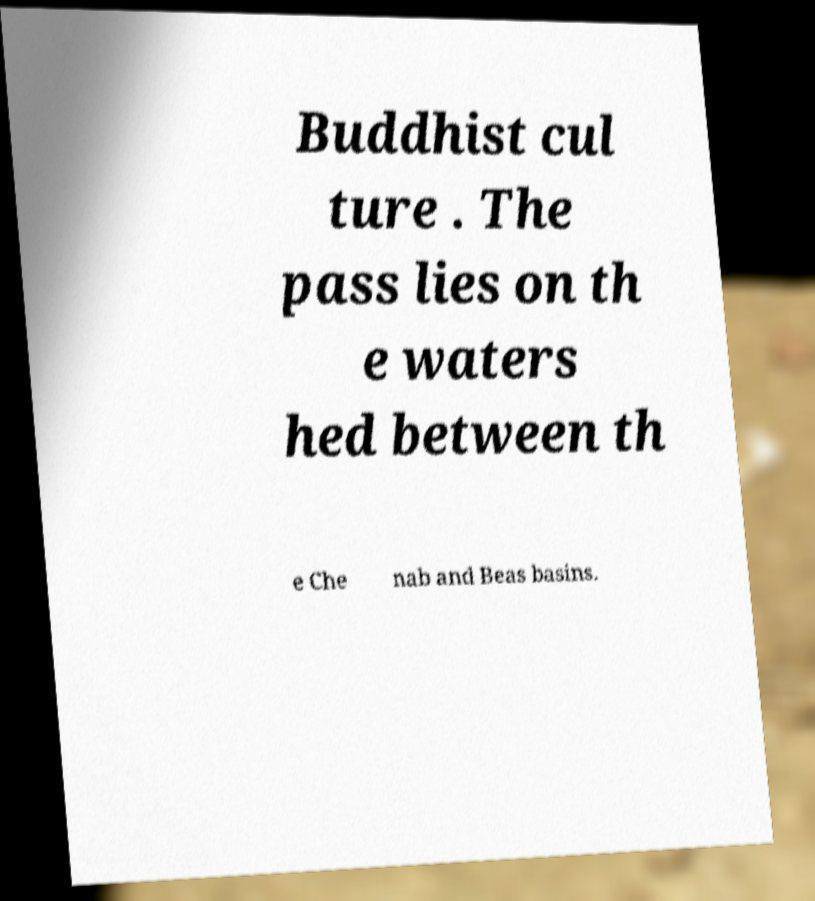Could you assist in decoding the text presented in this image and type it out clearly? Buddhist cul ture . The pass lies on th e waters hed between th e Che nab and Beas basins. 